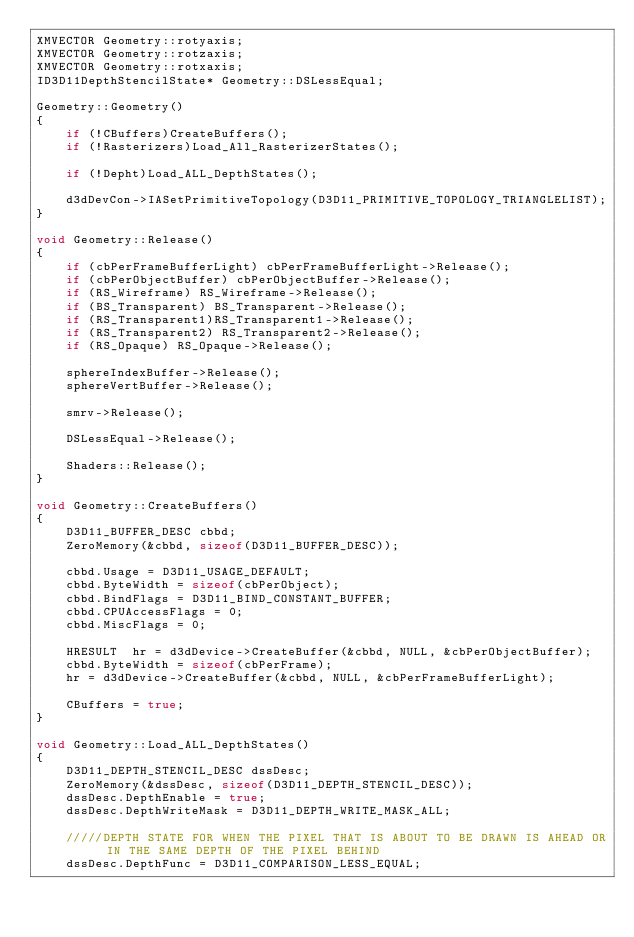<code> <loc_0><loc_0><loc_500><loc_500><_C++_>XMVECTOR Geometry::rotyaxis;
XMVECTOR Geometry::rotzaxis;
XMVECTOR Geometry::rotxaxis;
ID3D11DepthStencilState* Geometry::DSLessEqual;

Geometry::Geometry()
{
    if (!CBuffers)CreateBuffers();
    if (!Rasterizers)Load_All_RasterizerStates();

    if (!Depht)Load_ALL_DepthStates();

    d3dDevCon->IASetPrimitiveTopology(D3D11_PRIMITIVE_TOPOLOGY_TRIANGLELIST);   
}

void Geometry::Release()
{
    if (cbPerFrameBufferLight) cbPerFrameBufferLight->Release();
    if (cbPerObjectBuffer) cbPerObjectBuffer->Release();
    if (RS_Wireframe) RS_Wireframe->Release(); 
    if (BS_Transparent) BS_Transparent->Release();
    if (RS_Transparent1)RS_Transparent1->Release();
    if (RS_Transparent2) RS_Transparent2->Release();
    if (RS_Opaque) RS_Opaque->Release();

    sphereIndexBuffer->Release();
    sphereVertBuffer->Release();

    smrv->Release();

    DSLessEqual->Release();

    Shaders::Release();
}

void Geometry::CreateBuffers()
{
    D3D11_BUFFER_DESC cbbd;
    ZeroMemory(&cbbd, sizeof(D3D11_BUFFER_DESC));

    cbbd.Usage = D3D11_USAGE_DEFAULT;
    cbbd.ByteWidth = sizeof(cbPerObject);
    cbbd.BindFlags = D3D11_BIND_CONSTANT_BUFFER;
    cbbd.CPUAccessFlags = 0;
    cbbd.MiscFlags = 0;

    HRESULT  hr = d3dDevice->CreateBuffer(&cbbd, NULL, &cbPerObjectBuffer);
    cbbd.ByteWidth = sizeof(cbPerFrame);
    hr = d3dDevice->CreateBuffer(&cbbd, NULL, &cbPerFrameBufferLight);

    CBuffers = true;
}

void Geometry::Load_ALL_DepthStates()
{
    D3D11_DEPTH_STENCIL_DESC dssDesc;
    ZeroMemory(&dssDesc, sizeof(D3D11_DEPTH_STENCIL_DESC));
    dssDesc.DepthEnable = true;
    dssDesc.DepthWriteMask = D3D11_DEPTH_WRITE_MASK_ALL;

    /////DEPTH STATE FOR WHEN THE PIXEL THAT IS ABOUT TO BE DRAWN IS AHEAD OR IN THE SAME DEPTH OF THE PIXEL BEHIND
    dssDesc.DepthFunc = D3D11_COMPARISON_LESS_EQUAL;</code> 